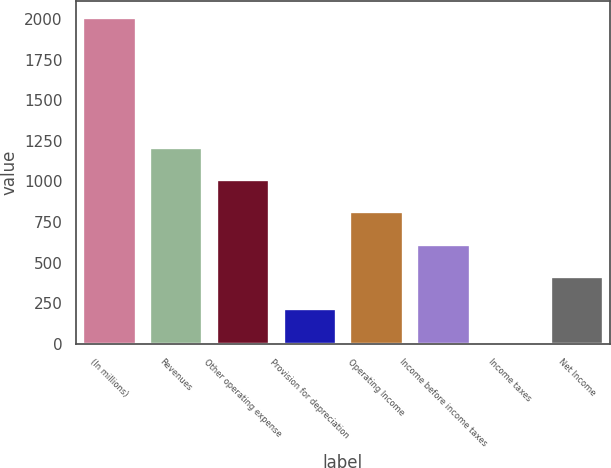<chart> <loc_0><loc_0><loc_500><loc_500><bar_chart><fcel>(In millions)<fcel>Revenues<fcel>Other operating expense<fcel>Provision for depreciation<fcel>Operating Income<fcel>Income before income taxes<fcel>Income taxes<fcel>Net Income<nl><fcel>2010<fcel>1214<fcel>1015<fcel>219<fcel>816<fcel>617<fcel>20<fcel>418<nl></chart> 